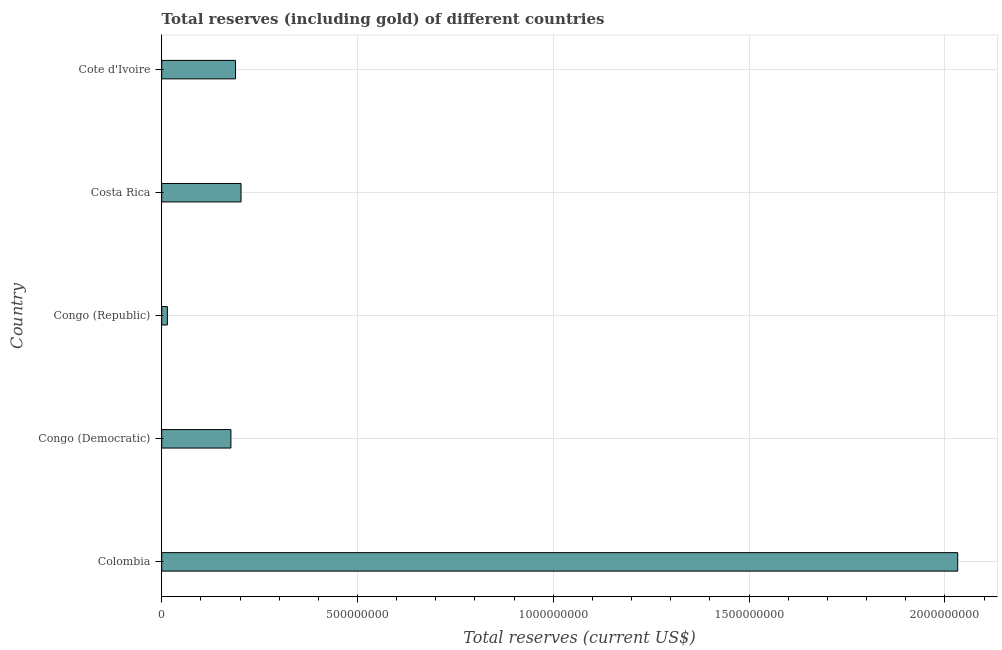Does the graph contain grids?
Your answer should be very brief. Yes. What is the title of the graph?
Provide a succinct answer. Total reserves (including gold) of different countries. What is the label or title of the X-axis?
Ensure brevity in your answer.  Total reserves (current US$). What is the label or title of the Y-axis?
Give a very brief answer. Country. What is the total reserves (including gold) in Congo (Republic)?
Your answer should be compact. 1.45e+07. Across all countries, what is the maximum total reserves (including gold)?
Keep it short and to the point. 2.03e+09. Across all countries, what is the minimum total reserves (including gold)?
Provide a succinct answer. 1.45e+07. In which country was the total reserves (including gold) maximum?
Your response must be concise. Colombia. In which country was the total reserves (including gold) minimum?
Keep it short and to the point. Congo (Republic). What is the sum of the total reserves (including gold)?
Give a very brief answer. 2.62e+09. What is the difference between the total reserves (including gold) in Congo (Democratic) and Cote d'Ivoire?
Your answer should be very brief. -1.17e+07. What is the average total reserves (including gold) per country?
Provide a short and direct response. 5.23e+08. What is the median total reserves (including gold)?
Your response must be concise. 1.89e+08. In how many countries, is the total reserves (including gold) greater than 1400000000 US$?
Provide a succinct answer. 1. What is the ratio of the total reserves (including gold) in Congo (Democratic) to that in Congo (Republic)?
Your answer should be compact. 12.23. Is the total reserves (including gold) in Colombia less than that in Congo (Republic)?
Offer a very short reply. No. Is the difference between the total reserves (including gold) in Congo (Democratic) and Congo (Republic) greater than the difference between any two countries?
Your response must be concise. No. What is the difference between the highest and the second highest total reserves (including gold)?
Provide a short and direct response. 1.83e+09. Is the sum of the total reserves (including gold) in Congo (Democratic) and Costa Rica greater than the maximum total reserves (including gold) across all countries?
Give a very brief answer. No. What is the difference between the highest and the lowest total reserves (including gold)?
Keep it short and to the point. 2.02e+09. How many countries are there in the graph?
Ensure brevity in your answer.  5. What is the Total reserves (current US$) of Colombia?
Offer a terse response. 2.03e+09. What is the Total reserves (current US$) of Congo (Democratic)?
Offer a terse response. 1.77e+08. What is the Total reserves (current US$) in Congo (Republic)?
Provide a short and direct response. 1.45e+07. What is the Total reserves (current US$) in Costa Rica?
Your response must be concise. 2.03e+08. What is the Total reserves (current US$) of Cote d'Ivoire?
Give a very brief answer. 1.89e+08. What is the difference between the Total reserves (current US$) in Colombia and Congo (Democratic)?
Give a very brief answer. 1.86e+09. What is the difference between the Total reserves (current US$) in Colombia and Congo (Republic)?
Your answer should be very brief. 2.02e+09. What is the difference between the Total reserves (current US$) in Colombia and Costa Rica?
Your answer should be compact. 1.83e+09. What is the difference between the Total reserves (current US$) in Colombia and Cote d'Ivoire?
Your response must be concise. 1.84e+09. What is the difference between the Total reserves (current US$) in Congo (Democratic) and Congo (Republic)?
Your answer should be very brief. 1.62e+08. What is the difference between the Total reserves (current US$) in Congo (Democratic) and Costa Rica?
Provide a succinct answer. -2.58e+07. What is the difference between the Total reserves (current US$) in Congo (Democratic) and Cote d'Ivoire?
Your response must be concise. -1.17e+07. What is the difference between the Total reserves (current US$) in Congo (Republic) and Costa Rica?
Offer a very short reply. -1.88e+08. What is the difference between the Total reserves (current US$) in Congo (Republic) and Cote d'Ivoire?
Make the answer very short. -1.74e+08. What is the difference between the Total reserves (current US$) in Costa Rica and Cote d'Ivoire?
Your response must be concise. 1.41e+07. What is the ratio of the Total reserves (current US$) in Colombia to that in Congo (Democratic)?
Keep it short and to the point. 11.5. What is the ratio of the Total reserves (current US$) in Colombia to that in Congo (Republic)?
Your answer should be very brief. 140.64. What is the ratio of the Total reserves (current US$) in Colombia to that in Costa Rica?
Provide a short and direct response. 10.04. What is the ratio of the Total reserves (current US$) in Colombia to that in Cote d'Ivoire?
Provide a short and direct response. 10.78. What is the ratio of the Total reserves (current US$) in Congo (Democratic) to that in Congo (Republic)?
Your answer should be compact. 12.23. What is the ratio of the Total reserves (current US$) in Congo (Democratic) to that in Costa Rica?
Give a very brief answer. 0.87. What is the ratio of the Total reserves (current US$) in Congo (Democratic) to that in Cote d'Ivoire?
Provide a short and direct response. 0.94. What is the ratio of the Total reserves (current US$) in Congo (Republic) to that in Costa Rica?
Ensure brevity in your answer.  0.07. What is the ratio of the Total reserves (current US$) in Congo (Republic) to that in Cote d'Ivoire?
Your answer should be very brief. 0.08. What is the ratio of the Total reserves (current US$) in Costa Rica to that in Cote d'Ivoire?
Provide a succinct answer. 1.07. 